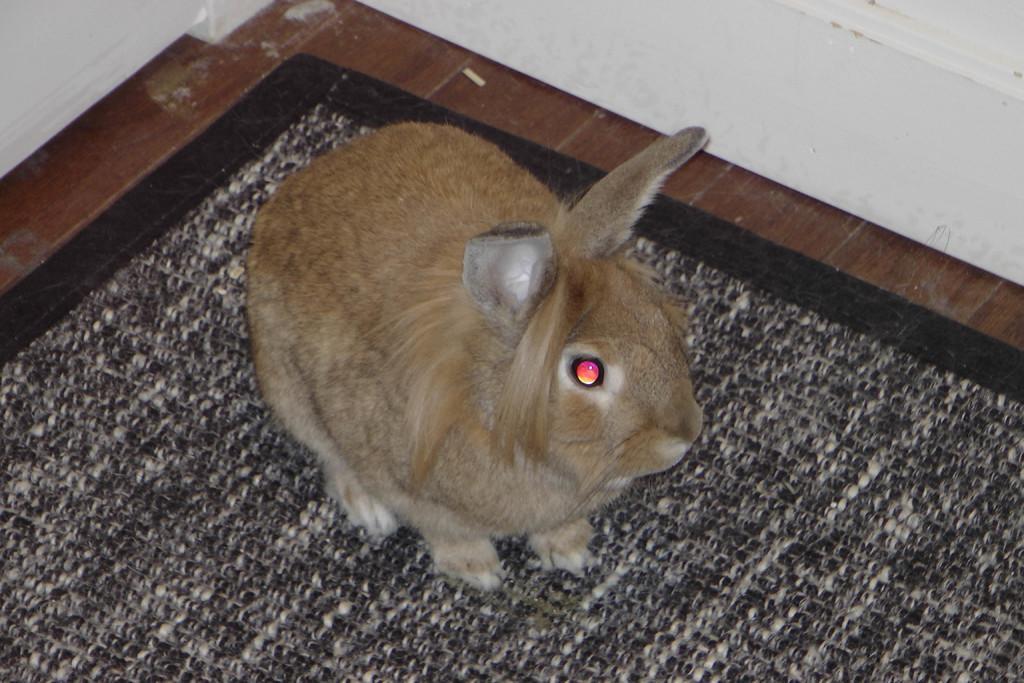How would you summarize this image in a sentence or two? In this image there is a rabbit standing on the mat. In the background of the image there is a wall. 